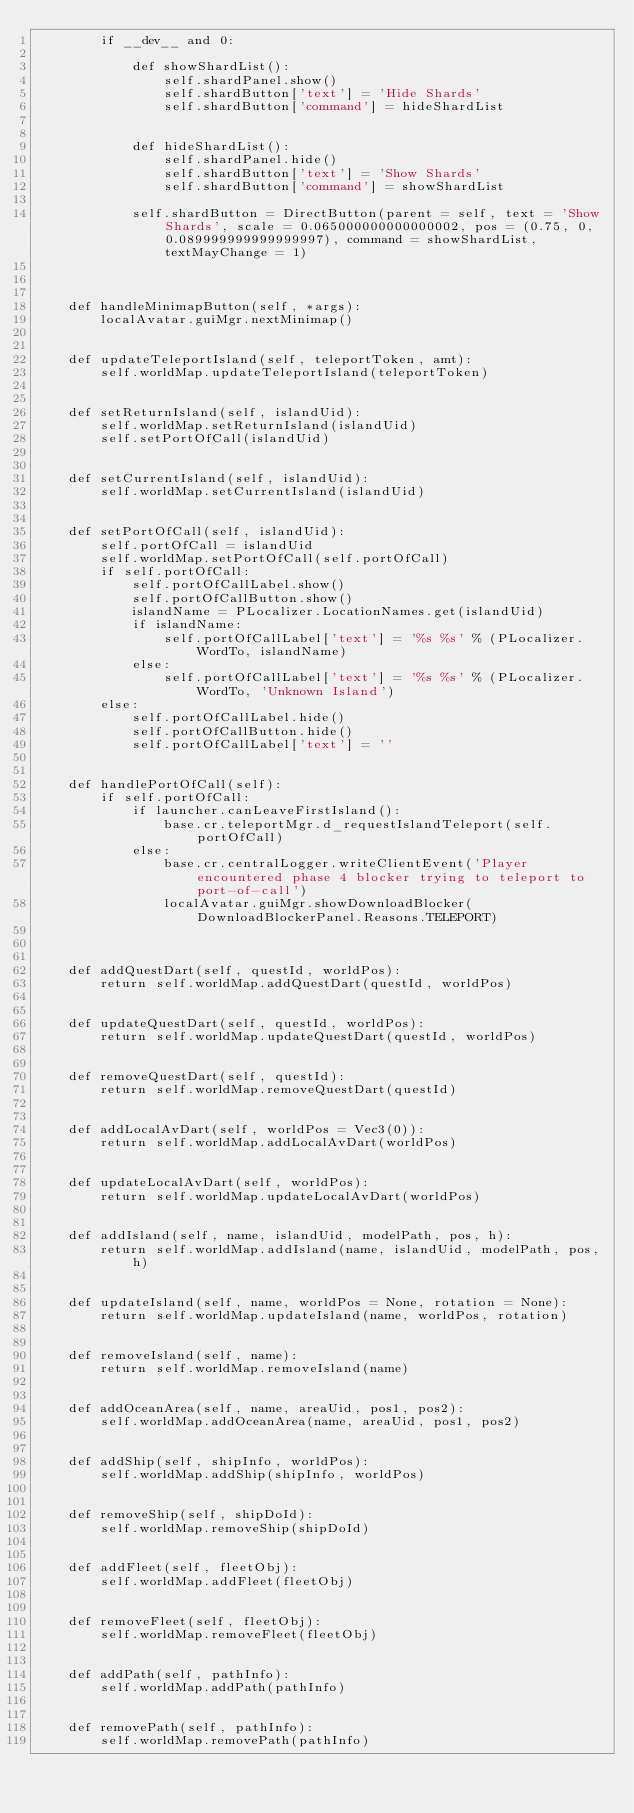Convert code to text. <code><loc_0><loc_0><loc_500><loc_500><_Python_>        if __dev__ and 0:
            
            def showShardList():
                self.shardPanel.show()
                self.shardButton['text'] = 'Hide Shards'
                self.shardButton['command'] = hideShardList

            
            def hideShardList():
                self.shardPanel.hide()
                self.shardButton['text'] = 'Show Shards'
                self.shardButton['command'] = showShardList

            self.shardButton = DirectButton(parent = self, text = 'Show Shards', scale = 0.065000000000000002, pos = (0.75, 0, 0.089999999999999997), command = showShardList, textMayChange = 1)
        

    
    def handleMinimapButton(self, *args):
        localAvatar.guiMgr.nextMinimap()

    
    def updateTeleportIsland(self, teleportToken, amt):
        self.worldMap.updateTeleportIsland(teleportToken)

    
    def setReturnIsland(self, islandUid):
        self.worldMap.setReturnIsland(islandUid)
        self.setPortOfCall(islandUid)

    
    def setCurrentIsland(self, islandUid):
        self.worldMap.setCurrentIsland(islandUid)

    
    def setPortOfCall(self, islandUid):
        self.portOfCall = islandUid
        self.worldMap.setPortOfCall(self.portOfCall)
        if self.portOfCall:
            self.portOfCallLabel.show()
            self.portOfCallButton.show()
            islandName = PLocalizer.LocationNames.get(islandUid)
            if islandName:
                self.portOfCallLabel['text'] = '%s %s' % (PLocalizer.WordTo, islandName)
            else:
                self.portOfCallLabel['text'] = '%s %s' % (PLocalizer.WordTo, 'Unknown Island')
        else:
            self.portOfCallLabel.hide()
            self.portOfCallButton.hide()
            self.portOfCallLabel['text'] = ''

    
    def handlePortOfCall(self):
        if self.portOfCall:
            if launcher.canLeaveFirstIsland():
                base.cr.teleportMgr.d_requestIslandTeleport(self.portOfCall)
            else:
                base.cr.centralLogger.writeClientEvent('Player encountered phase 4 blocker trying to teleport to port-of-call')
                localAvatar.guiMgr.showDownloadBlocker(DownloadBlockerPanel.Reasons.TELEPORT)
        

    
    def addQuestDart(self, questId, worldPos):
        return self.worldMap.addQuestDart(questId, worldPos)

    
    def updateQuestDart(self, questId, worldPos):
        return self.worldMap.updateQuestDart(questId, worldPos)

    
    def removeQuestDart(self, questId):
        return self.worldMap.removeQuestDart(questId)

    
    def addLocalAvDart(self, worldPos = Vec3(0)):
        return self.worldMap.addLocalAvDart(worldPos)

    
    def updateLocalAvDart(self, worldPos):
        return self.worldMap.updateLocalAvDart(worldPos)

    
    def addIsland(self, name, islandUid, modelPath, pos, h):
        return self.worldMap.addIsland(name, islandUid, modelPath, pos, h)

    
    def updateIsland(self, name, worldPos = None, rotation = None):
        return self.worldMap.updateIsland(name, worldPos, rotation)

    
    def removeIsland(self, name):
        return self.worldMap.removeIsland(name)

    
    def addOceanArea(self, name, areaUid, pos1, pos2):
        self.worldMap.addOceanArea(name, areaUid, pos1, pos2)

    
    def addShip(self, shipInfo, worldPos):
        self.worldMap.addShip(shipInfo, worldPos)

    
    def removeShip(self, shipDoId):
        self.worldMap.removeShip(shipDoId)

    
    def addFleet(self, fleetObj):
        self.worldMap.addFleet(fleetObj)

    
    def removeFleet(self, fleetObj):
        self.worldMap.removeFleet(fleetObj)

    
    def addPath(self, pathInfo):
        self.worldMap.addPath(pathInfo)

    
    def removePath(self, pathInfo):
        self.worldMap.removePath(pathInfo)


</code> 